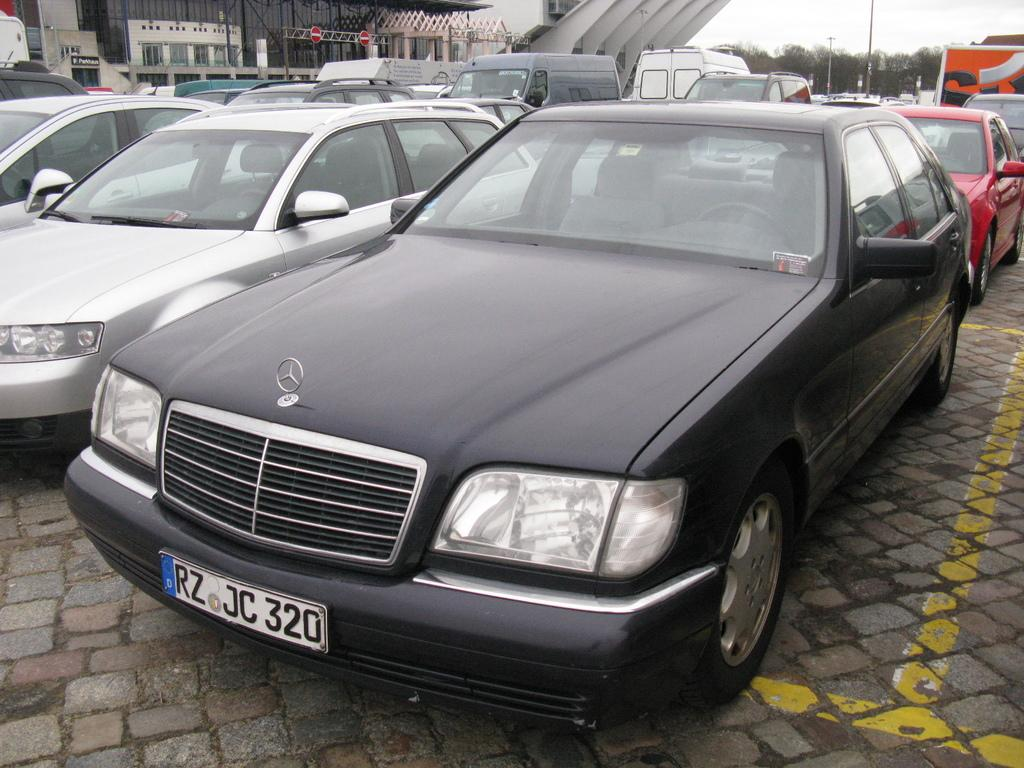What is the main subject of the image? The main subject of the image is many vehicles. What can be observed on the vehicles in the image? The vehicles have number plates. What can be seen in the background of the image? There are buildings and trees in the background of the image. What type of science experiment is being conducted with the vehicles in the image? There is no indication of a science experiment being conducted in the image; it simply shows vehicles with number plates and a background of buildings and trees. 